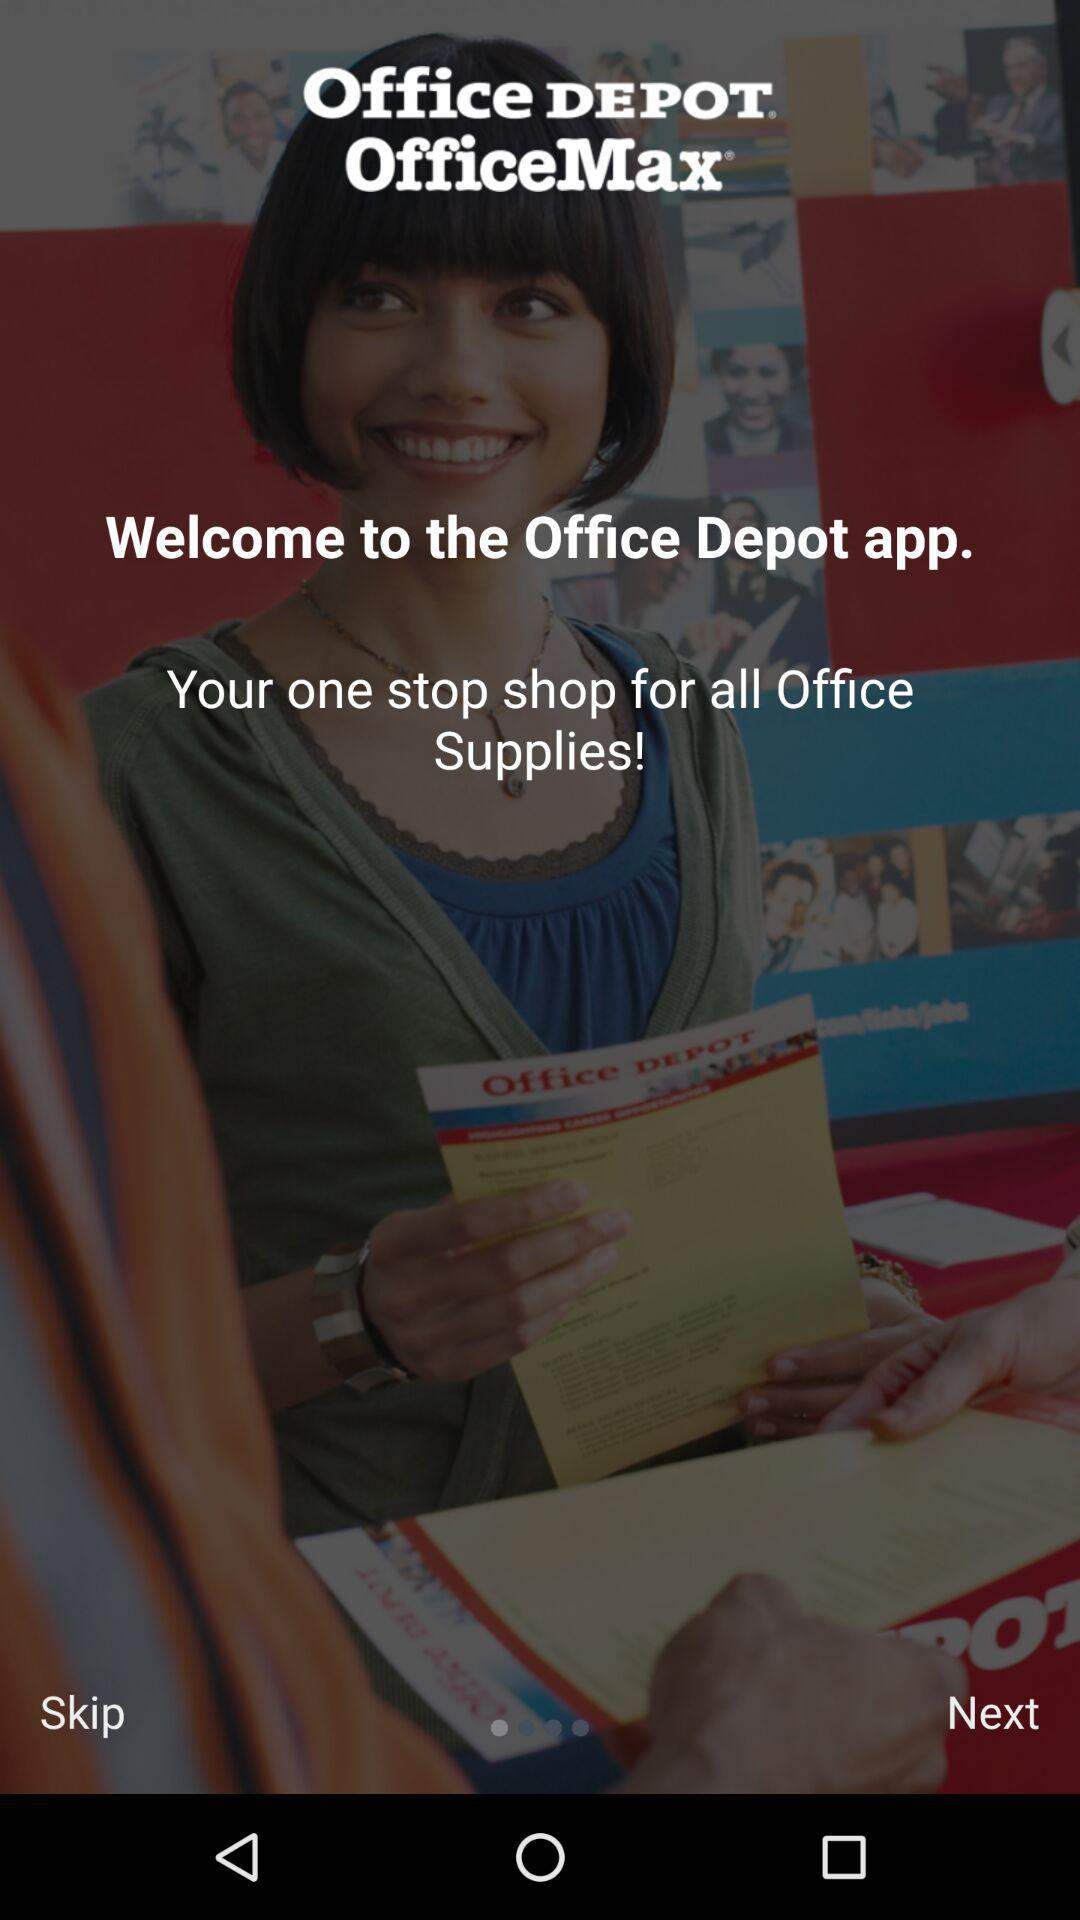What is the application name? The application name is "Office DEPOT". 